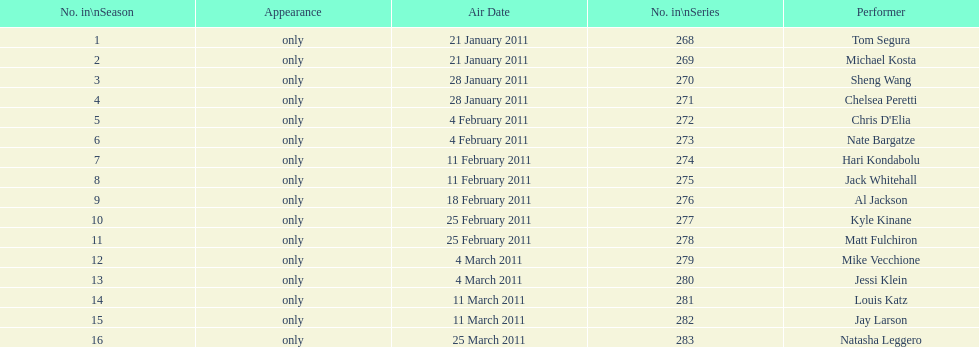What was hari's last name? Kondabolu. 